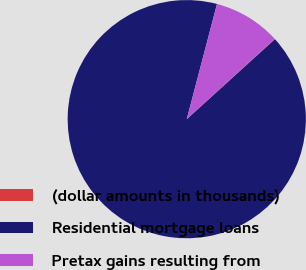Convert chart to OTSL. <chart><loc_0><loc_0><loc_500><loc_500><pie_chart><fcel>(dollar amounts in thousands)<fcel>Residential mortgage loans<fcel>Pretax gains resulting from<nl><fcel>0.06%<fcel>90.81%<fcel>9.13%<nl></chart> 